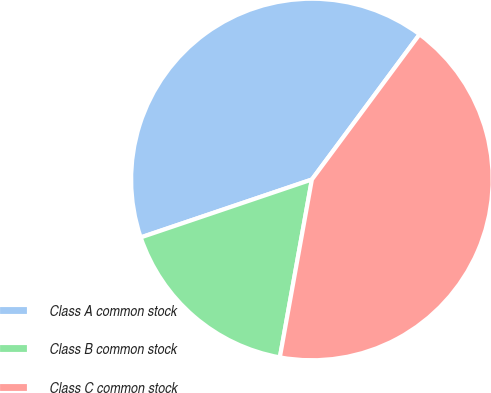<chart> <loc_0><loc_0><loc_500><loc_500><pie_chart><fcel>Class A common stock<fcel>Class B common stock<fcel>Class C common stock<nl><fcel>40.35%<fcel>16.97%<fcel>42.68%<nl></chart> 